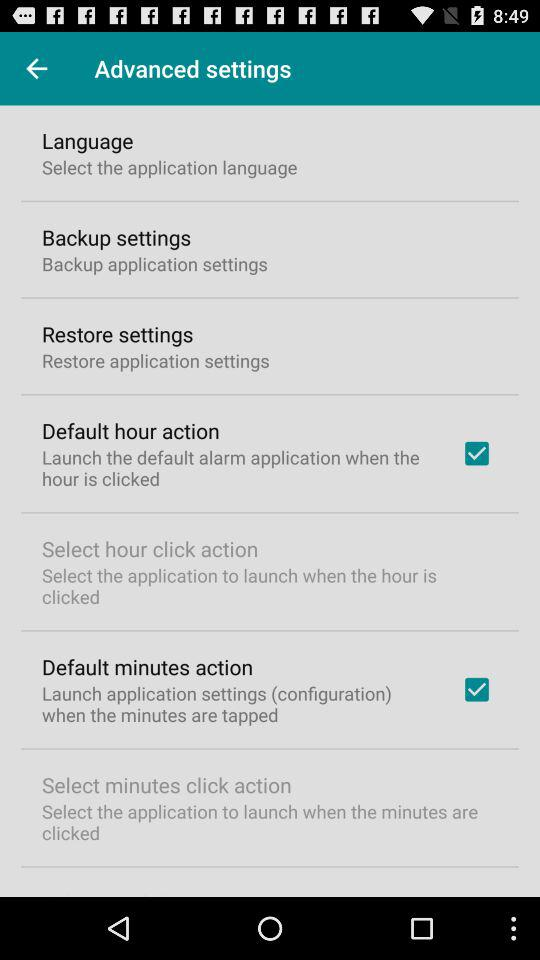How many items in the 'Advanced settings' screen have a checkbox?
Answer the question using a single word or phrase. 2 